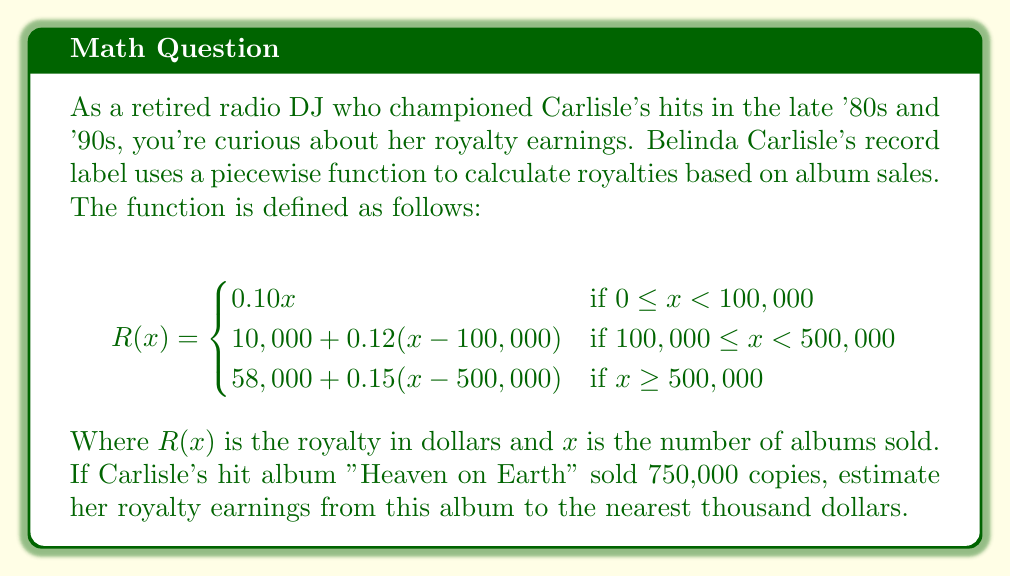Could you help me with this problem? To solve this problem, we need to use the piecewise function given and determine which piece applies to the sales figure of 750,000 albums.

1. First, we observe that 750,000 is greater than or equal to 500,000, so we'll use the third piece of the function:

   $$R(x) = 58,000 + 0.15(x - 500,000)$$

2. Now, let's substitute x = 750,000 into this equation:

   $$R(750,000) = 58,000 + 0.15(750,000 - 500,000)$$

3. Simplify the expression inside the parentheses:

   $$R(750,000) = 58,000 + 0.15(250,000)$$

4. Multiply 0.15 by 250,000:

   $$R(750,000) = 58,000 + 37,500$$

5. Add the results:

   $$R(750,000) = 95,500$$

6. Rounding to the nearest thousand dollars:

   $$R(750,000) \approx 96,000$$

Therefore, Belinda Carlisle's estimated royalty earnings from "Heaven on Earth" would be approximately $96,000.
Answer: $96,000 